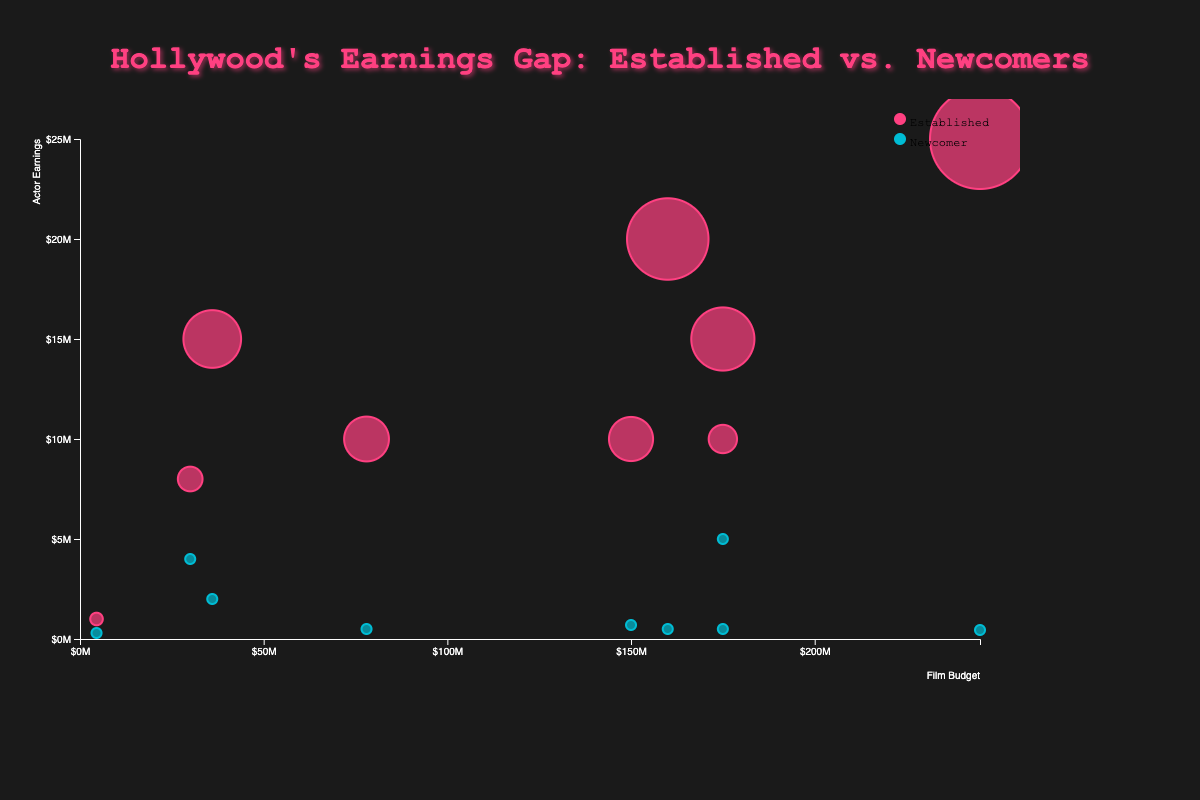What is the title of the chart? The title is located at the top center of the chart and reads "Hollywood's Earnings Gap: Established vs. Newcomers".
Answer: Hollywood's Earnings Gap: Established vs. Newcomers How many films have a budget over $150 million? The x-axis represents film budgets. By counting the number of bubbles with a budget (x-value) exceeding $150 million, we find that 5 films have a budget over $150 million.
Answer: 5 Which film has the highest earnings disparity between established and newcomer actors? The size of the bubbles represents the earnings disparity. The largest bubble corresponds to "Star Wars: The Force Awakens".
Answer: Star Wars: The Force Awakens Which film has the lowest budget, and what are the earnings of the newcomer actor in that film? The x-axis indicates the film budgets. The bubble for "Get Out" is the furthest left. According to the tooltip, Allison Williams earns $300,000.
Answer: Get Out, $300,000 What is the average film budget shown in the chart? Film budgets are spread along the x-axis. Adding them up and dividing by the number of films (9) gives: (160 + 36 + 175 + 78 + 175 + 4.5 + 150 + 30 + 245)/9 ≈ 117.39 million.
Answer: ~$117.39 million Which actor earned the most among the newcomers and for which film? Comparing the vertical positions of newcomer actor bubbles along the y-axis, Lady Gaga, in “A Star is Born”, has the highest earnings.
Answer: Lady Gaga, A Star is Born How many films feature established actors earning more than $15 million? The bubbles above the $15 million mark on the y-axis represent these films. Counting these bubbles, we find 3 films feature established actors earning more than $15 million.
Answer: 3 What is the difference in earnings between the established and newcomer actors in "Inception"? The tooltip for "Inception" provides the information: $20,000,000 (Leonardo DiCaprio) - $500,000 (Tom Hardy) = $19,500,000.
Answer: $19,500,000 Which film has the smallest earnings disparity between established and newcomer actors, and what is the disparity? The smallest bubbles indicate the smallest disparities. "La La Land" has the smallest bubble. The disparity is $4,000,000 - $2,000,000 = $2,000,000.
Answer: La La Land, $2,000,000 